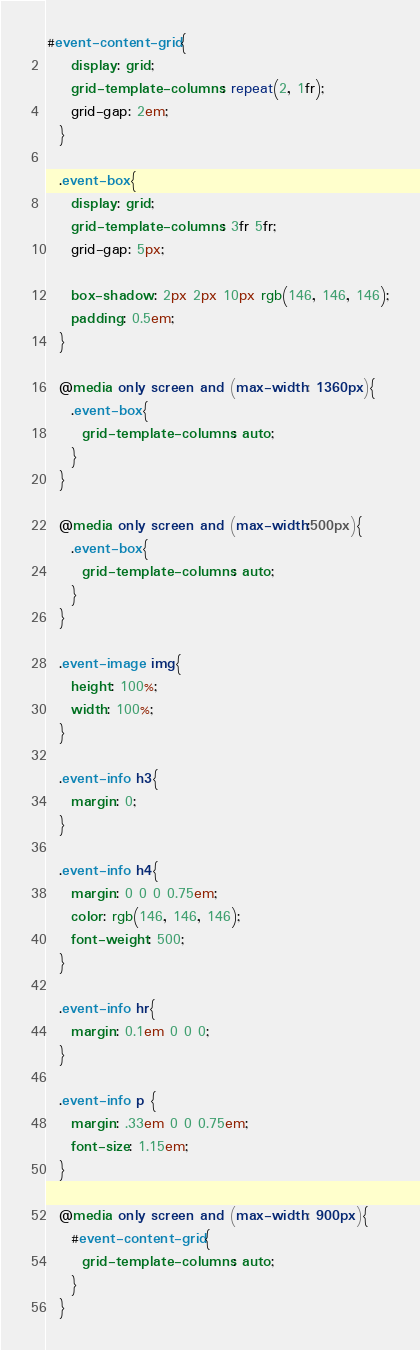<code> <loc_0><loc_0><loc_500><loc_500><_CSS_>#event-content-grid{
    display: grid;
    grid-template-columns: repeat(2, 1fr);
    grid-gap: 2em;
  }
  
  .event-box{
    display: grid;
    grid-template-columns: 3fr 5fr;
    grid-gap: 5px;
  
    box-shadow: 2px 2px 10px rgb(146, 146, 146);
    padding: 0.5em;
  }

  @media only screen and (max-width: 1360px){
    .event-box{
      grid-template-columns: auto;
    }
  }

  @media only screen and (max-width:500px){
    .event-box{
      grid-template-columns: auto;
    }
  }
  
  .event-image img{
    height: 100%;
    width: 100%;
  }
  
  .event-info h3{
    margin: 0;
  }
  
  .event-info h4{
    margin: 0 0 0 0.75em;
    color: rgb(146, 146, 146);
    font-weight: 500;
  }
  
  .event-info hr{
    margin: 0.1em 0 0 0;
  }
  
  .event-info p {
    margin: .33em 0 0 0.75em;
    font-size: 1.15em;
  }

  @media only screen and (max-width: 900px){
    #event-content-grid{
      grid-template-columns: auto;
    }
  }</code> 